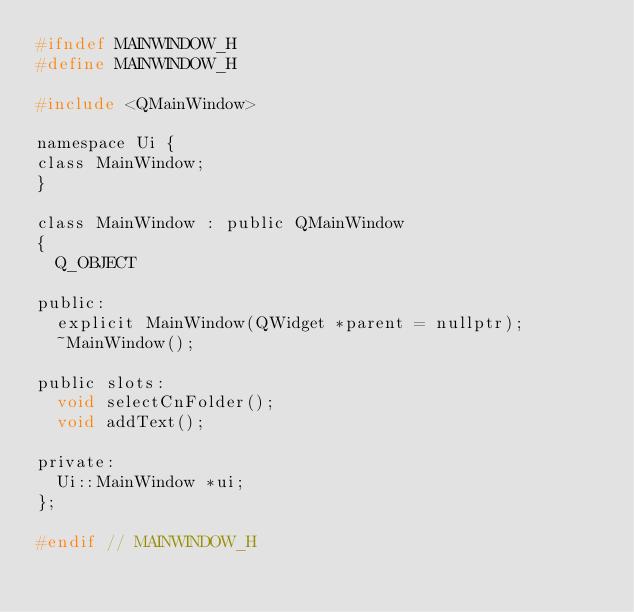<code> <loc_0><loc_0><loc_500><loc_500><_C_>#ifndef MAINWINDOW_H
#define MAINWINDOW_H

#include <QMainWindow>

namespace Ui {
class MainWindow;
}

class MainWindow : public QMainWindow
{
	Q_OBJECT

public:
	explicit MainWindow(QWidget *parent = nullptr);
	~MainWindow();

public slots:
	void selectCnFolder();
	void addText();

private:
	Ui::MainWindow *ui;
};

#endif // MAINWINDOW_H
</code> 